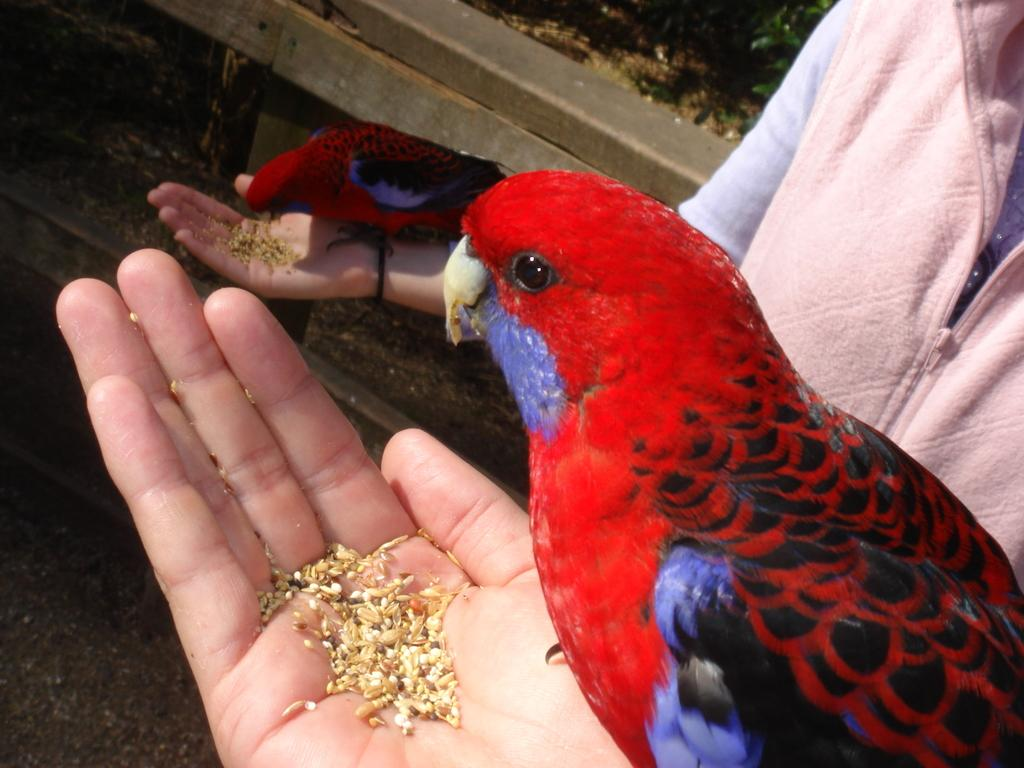What type of animals are in the image? There are two red parrots in the image. What are the parrots doing in the image? The parrots are eating food in the image. Who is providing the food for the parrots? There is a person on the right side of the image who is feeding the parrots. What is the person holding in their hand? The person is holding food in their hand. Are there any cobwebs visible in the image? There is no mention of cobwebs in the provided facts, and therefore it cannot be determined if any are present in the image. 